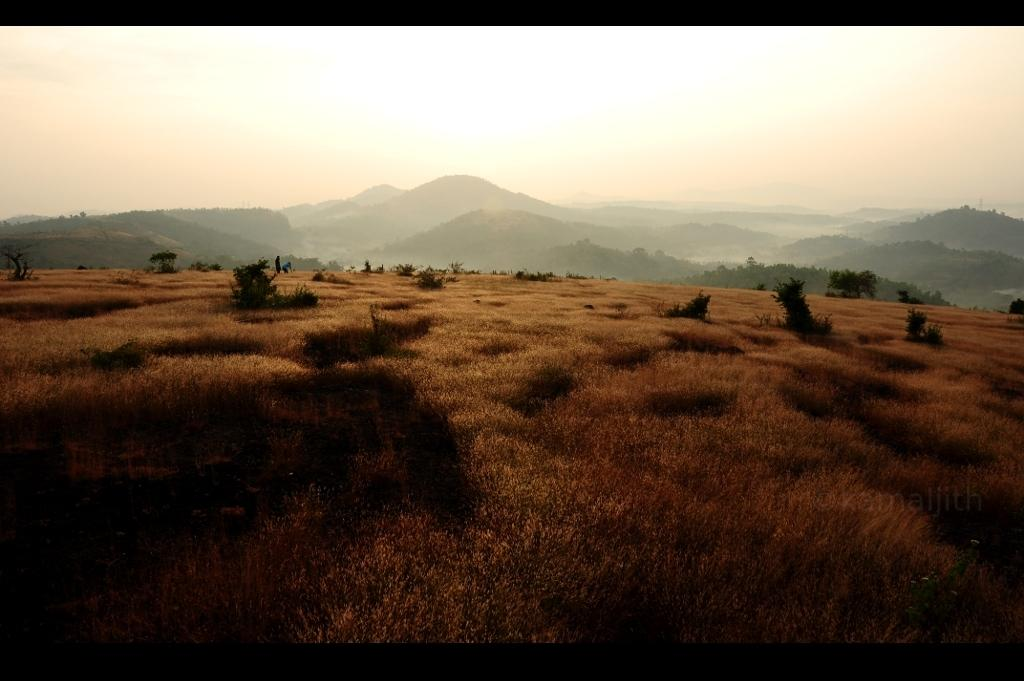What type of vegetation is present in the image? There is grass and plants in the image. What can be seen in the background of the image? Mountains and the sky are visible in the background of the image. What is the color of the top and bottom of the image? The top and bottom of the image have a black color. What direction are the plants moving in the image? The plants do not move in the image; they are stationary. Is there a battle taking place in the image? There is no battle present in the image. 